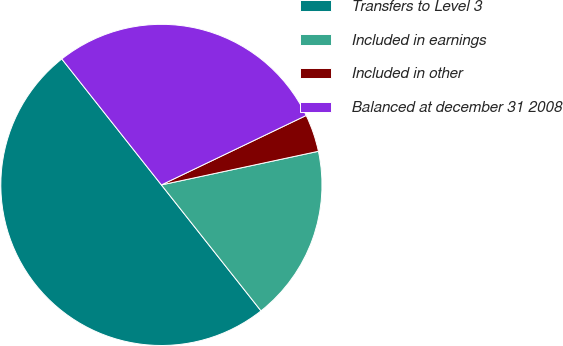Convert chart. <chart><loc_0><loc_0><loc_500><loc_500><pie_chart><fcel>Transfers to Level 3<fcel>Included in earnings<fcel>Included in other<fcel>Balanced at december 31 2008<nl><fcel>50.0%<fcel>17.71%<fcel>3.76%<fcel>28.53%<nl></chart> 